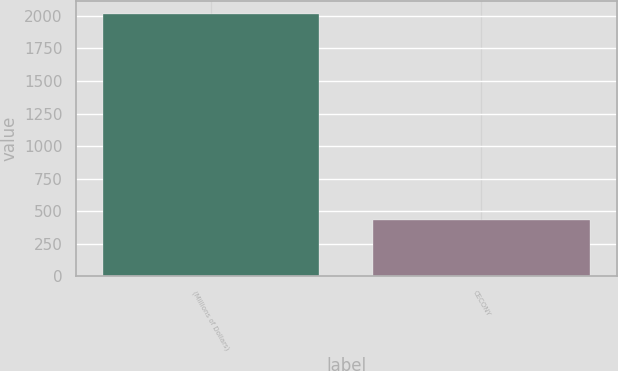Convert chart. <chart><loc_0><loc_0><loc_500><loc_500><bar_chart><fcel>(Millions of Dollars)<fcel>CECONY<nl><fcel>2014<fcel>433<nl></chart> 